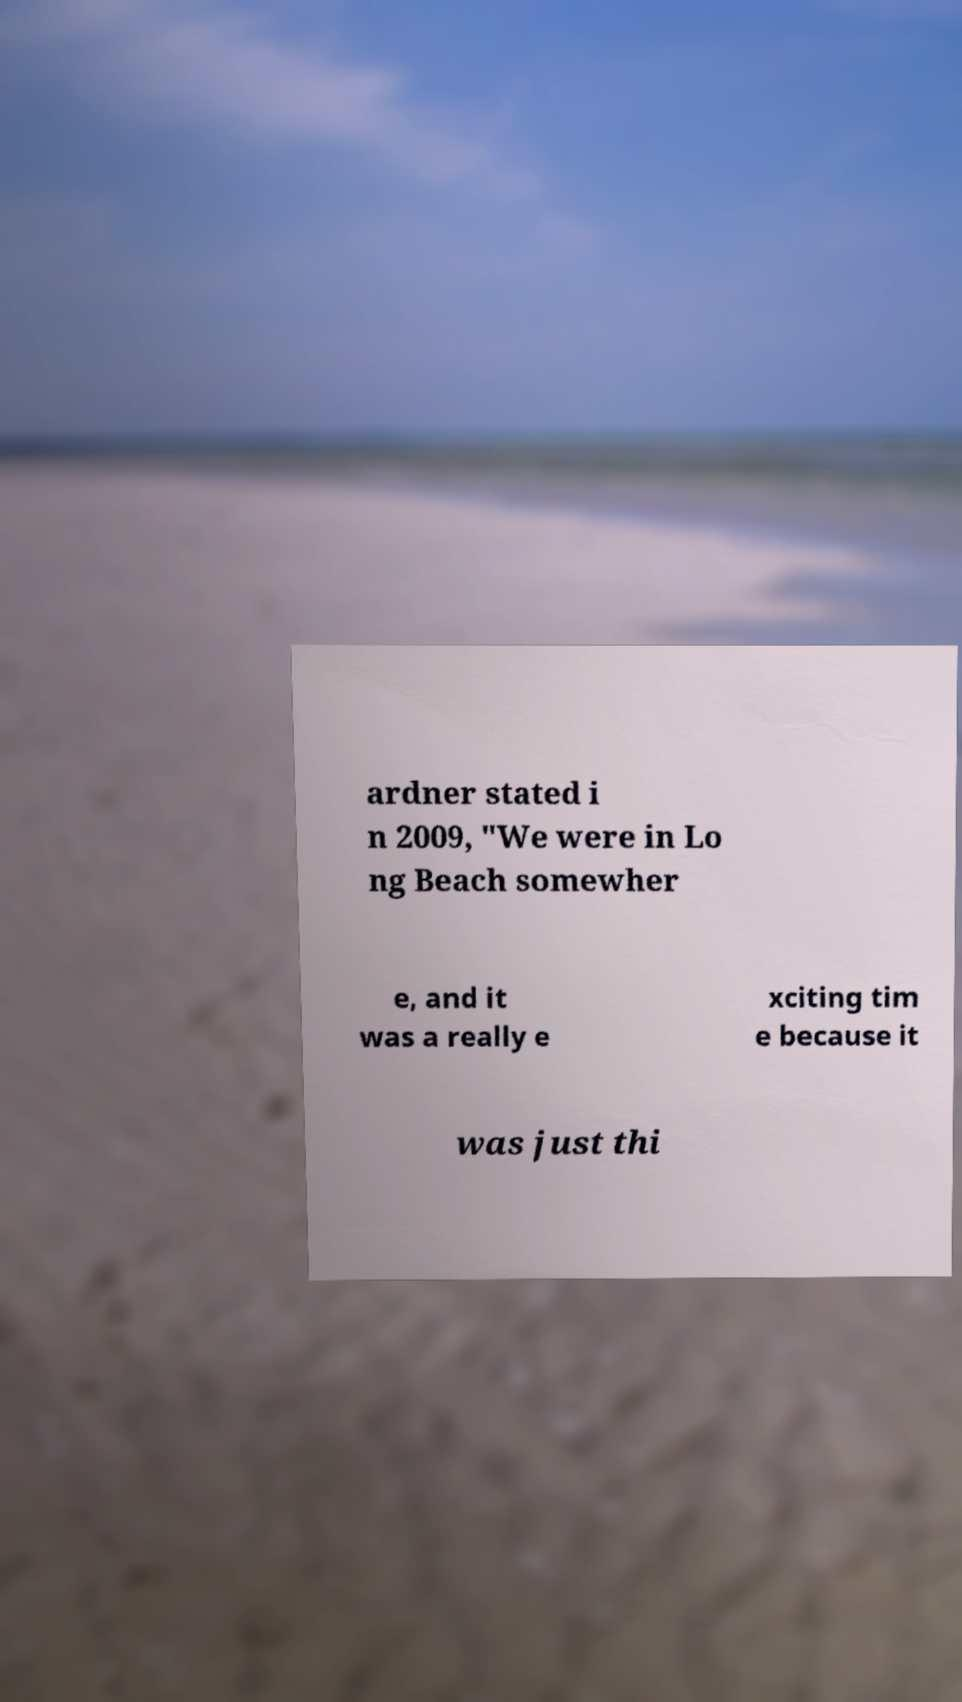What messages or text are displayed in this image? I need them in a readable, typed format. ardner stated i n 2009, "We were in Lo ng Beach somewher e, and it was a really e xciting tim e because it was just thi 